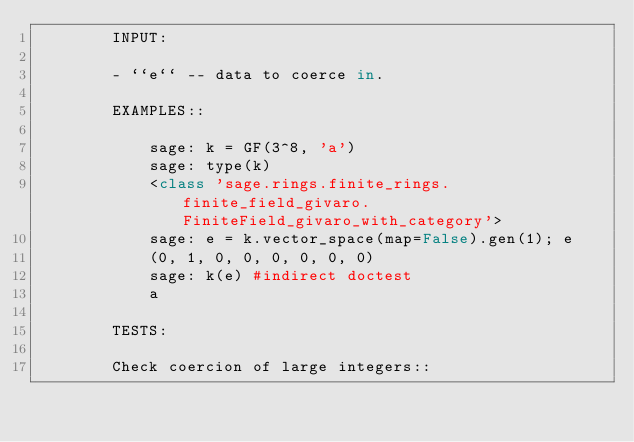<code> <loc_0><loc_0><loc_500><loc_500><_Cython_>        INPUT:

        - ``e`` -- data to coerce in.

        EXAMPLES::

            sage: k = GF(3^8, 'a')
            sage: type(k)
            <class 'sage.rings.finite_rings.finite_field_givaro.FiniteField_givaro_with_category'>
            sage: e = k.vector_space(map=False).gen(1); e
            (0, 1, 0, 0, 0, 0, 0, 0)
            sage: k(e) #indirect doctest
            a

        TESTS:

        Check coercion of large integers::
</code> 